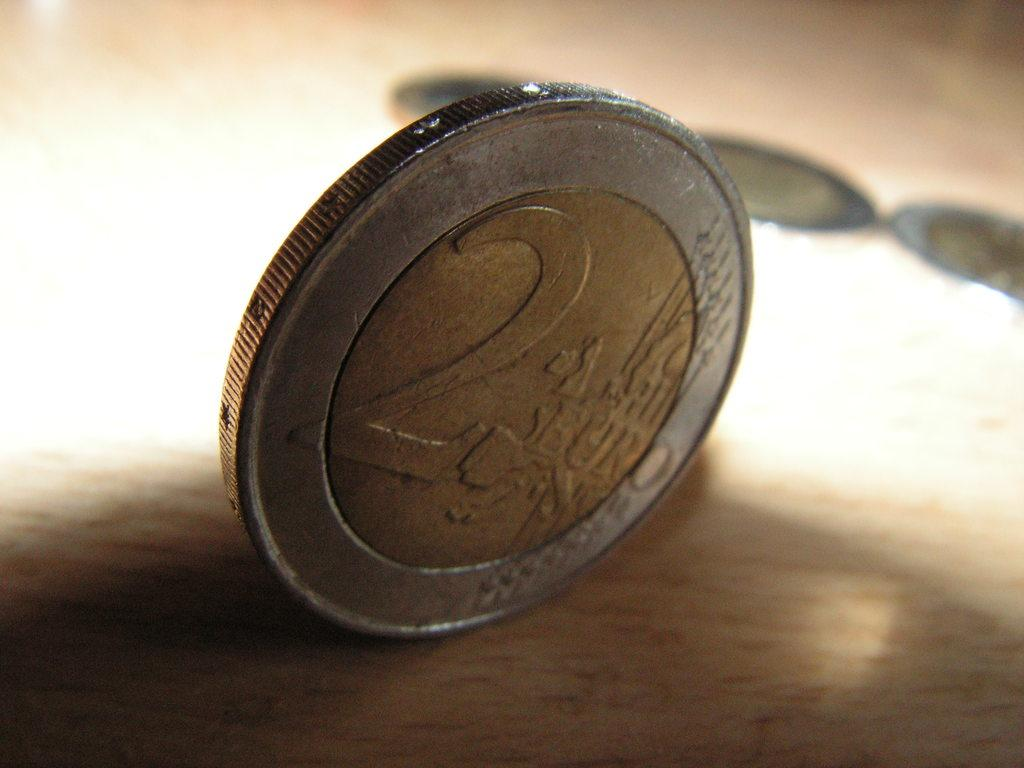Provide a one-sentence caption for the provided image. A euro standing upright worth a value of 2 euros. 